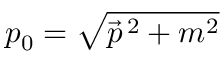<formula> <loc_0><loc_0><loc_500><loc_500>p _ { 0 } = \sqrt { { \vec { p } } ^ { \, 2 } + m ^ { 2 } }</formula> 